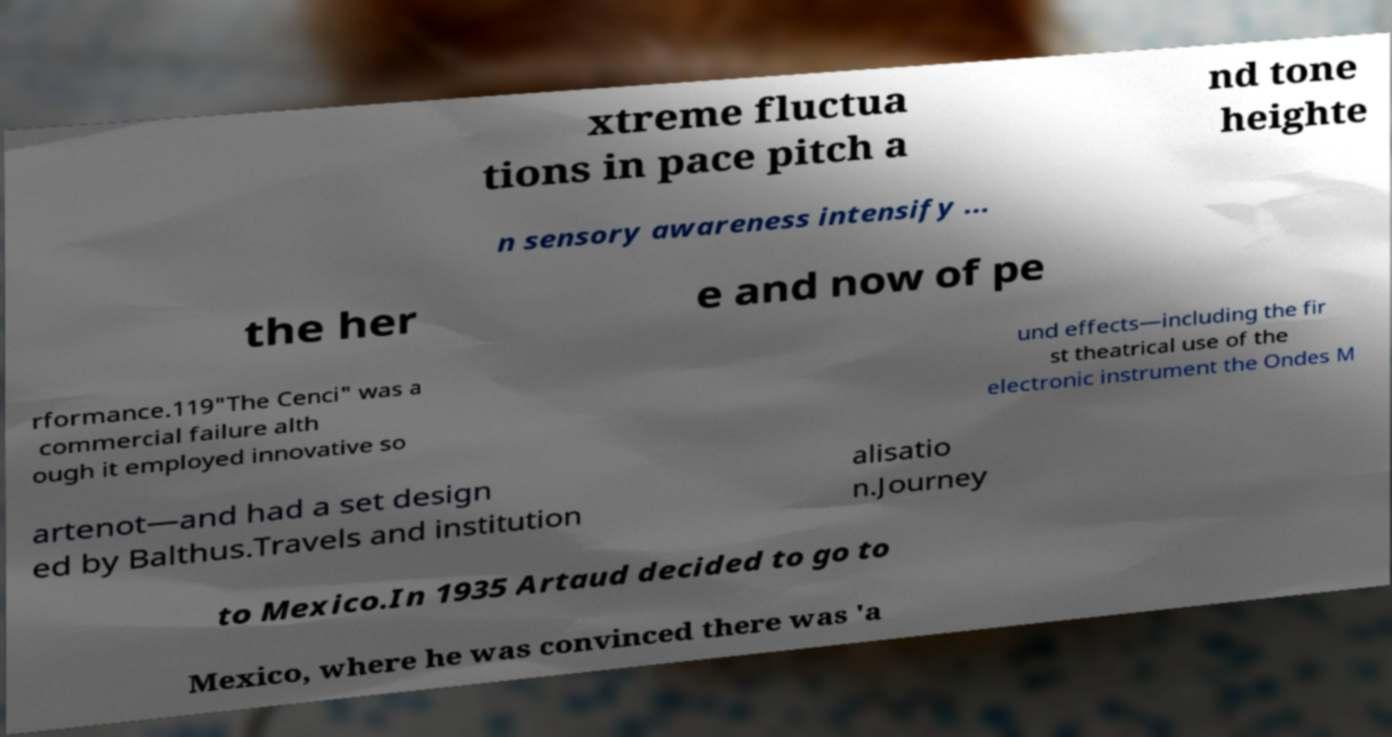I need the written content from this picture converted into text. Can you do that? xtreme fluctua tions in pace pitch a nd tone heighte n sensory awareness intensify ... the her e and now of pe rformance.119"The Cenci" was a commercial failure alth ough it employed innovative so und effects—including the fir st theatrical use of the electronic instrument the Ondes M artenot—and had a set design ed by Balthus.Travels and institution alisatio n.Journey to Mexico.In 1935 Artaud decided to go to Mexico, where he was convinced there was 'a 